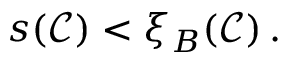<formula> <loc_0><loc_0><loc_500><loc_500>\begin{array} { r } { s ( \mathcal { C } ) < \xi _ { B } ( \mathcal { C } ) \, . } \end{array}</formula> 